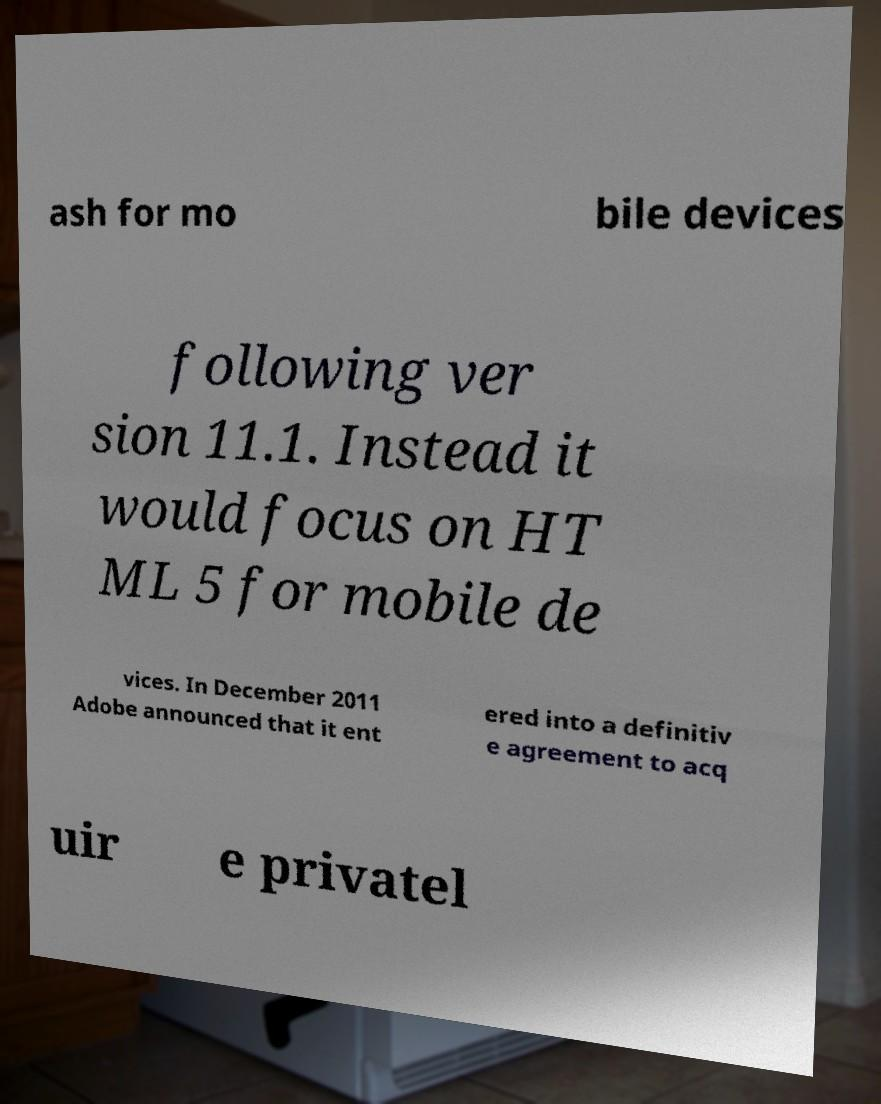Could you assist in decoding the text presented in this image and type it out clearly? ash for mo bile devices following ver sion 11.1. Instead it would focus on HT ML 5 for mobile de vices. In December 2011 Adobe announced that it ent ered into a definitiv e agreement to acq uir e privatel 